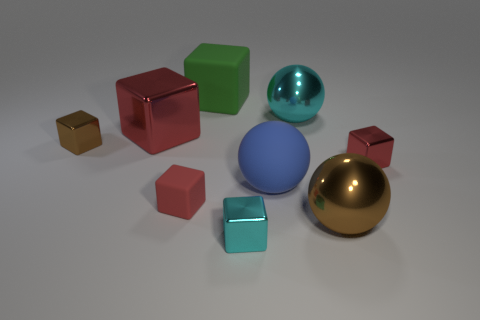What size is the cyan object that is the same shape as the large brown shiny object?
Offer a terse response. Large. What material is the cyan block?
Make the answer very short. Metal. The brown thing that is left of the tiny metal thing in front of the matte thing right of the large rubber cube is made of what material?
Ensure brevity in your answer.  Metal. What color is the other shiny thing that is the same shape as the large cyan shiny thing?
Keep it short and to the point. Brown. Is the color of the big cube on the left side of the big green thing the same as the rubber cube that is in front of the big red thing?
Offer a very short reply. Yes. Are there more small metallic blocks that are on the right side of the large cyan shiny object than small cyan metal spheres?
Ensure brevity in your answer.  Yes. How many other objects are the same size as the red matte block?
Offer a very short reply. 3. What number of cubes are both in front of the large matte ball and left of the large green matte cube?
Your response must be concise. 1. Are the cube right of the big blue rubber object and the big blue sphere made of the same material?
Keep it short and to the point. No. The large red metal thing that is behind the brown thing left of the small metal block in front of the big brown metallic sphere is what shape?
Keep it short and to the point. Cube. 